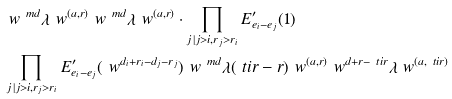<formula> <loc_0><loc_0><loc_500><loc_500>& \ w ^ { \ m d } \lambda \ w ^ { ( a , r ) } \ w ^ { \ m d } \lambda \ w ^ { ( a , r ) } \cdot \prod _ { j \, | j > i , r _ { j } > r _ { i } } E ^ { \prime } _ { e _ { i } - e _ { j } } ( 1 ) \\ & \prod _ { j \, | j > i , r _ { j } > r _ { i } } E ^ { \prime } _ { e _ { i } - e _ { j } } ( \ w ^ { d _ { i } + r _ { i } - d _ { j } - r _ { j } } ) \ w ^ { \ m d } \lambda ( \ t i r - r ) \ w ^ { ( a , r ) } \ w ^ { d + r - \ t i r } \lambda \ w ^ { ( a , \ t i r ) }</formula> 